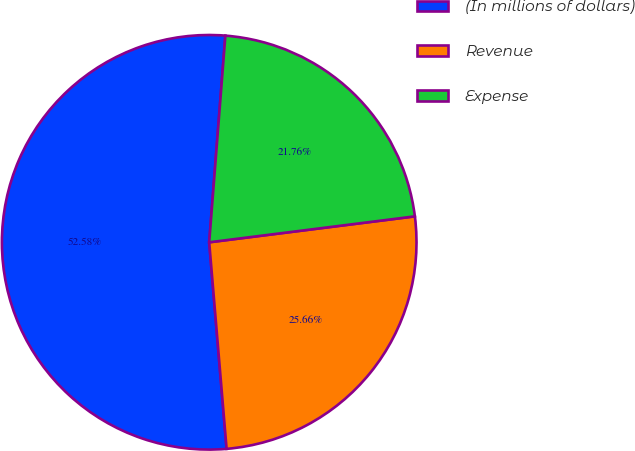Convert chart to OTSL. <chart><loc_0><loc_0><loc_500><loc_500><pie_chart><fcel>(In millions of dollars)<fcel>Revenue<fcel>Expense<nl><fcel>52.58%<fcel>25.66%<fcel>21.76%<nl></chart> 